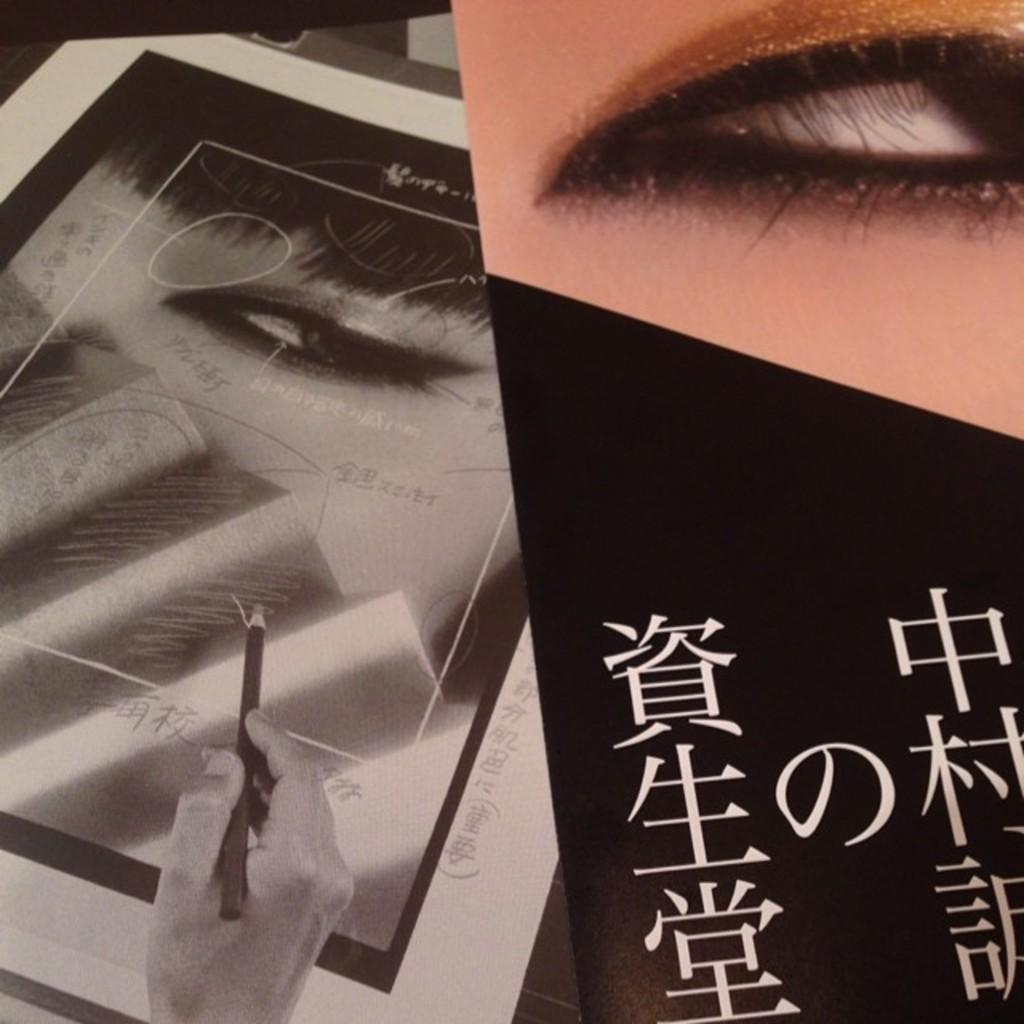What type of artwork is depicted in the image? The image is a collage. Can you describe a specific element within the collage? There is an eye of a person with text in the collage. What is another object or feature present in the collage? There is a hand holding a pencil on a poster in the collage. What color is the girl's suit in the image? There is no girl or suit present in the image; it is a collage featuring an eye with text and a hand holding a pencil on a poster. 